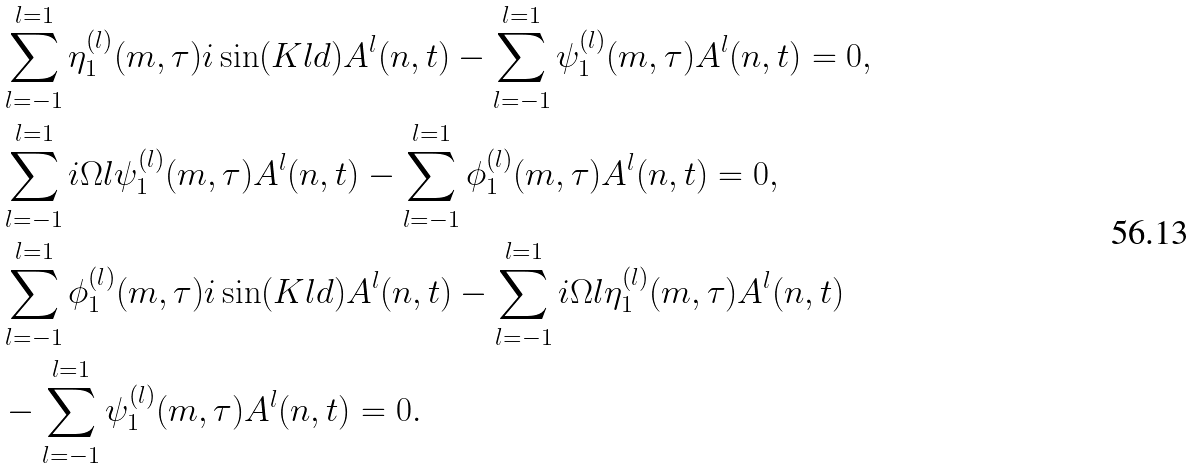Convert formula to latex. <formula><loc_0><loc_0><loc_500><loc_500>& \sum ^ { l = 1 } _ { l = - 1 } \eta ^ { ( l ) } _ { 1 } ( m , \tau ) i \sin ( K l d ) A ^ { l } ( n , t ) - \sum ^ { l = 1 } _ { l = - 1 } \psi ^ { ( l ) } _ { 1 } ( m , \tau ) A ^ { l } ( n , t ) = 0 , \\ & \sum ^ { l = 1 } _ { l = - 1 } i \Omega l \psi ^ { ( l ) } _ { 1 } ( m , \tau ) A ^ { l } ( n , t ) - \sum ^ { l = 1 } _ { l = - 1 } \phi ^ { ( l ) } _ { 1 } ( m , \tau ) A ^ { l } ( n , t ) = 0 , \\ & \sum ^ { l = 1 } _ { l = - 1 } \phi ^ { ( l ) } _ { 1 } ( m , \tau ) i \sin ( K l d ) A ^ { l } ( n , t ) - \sum ^ { l = 1 } _ { l = - 1 } i \Omega l \eta ^ { ( l ) } _ { 1 } ( m , \tau ) A ^ { l } ( n , t ) \\ & - \sum ^ { l = 1 } _ { l = - 1 } \psi ^ { ( l ) } _ { 1 } ( m , \tau ) A ^ { l } ( n , t ) = 0 .</formula> 